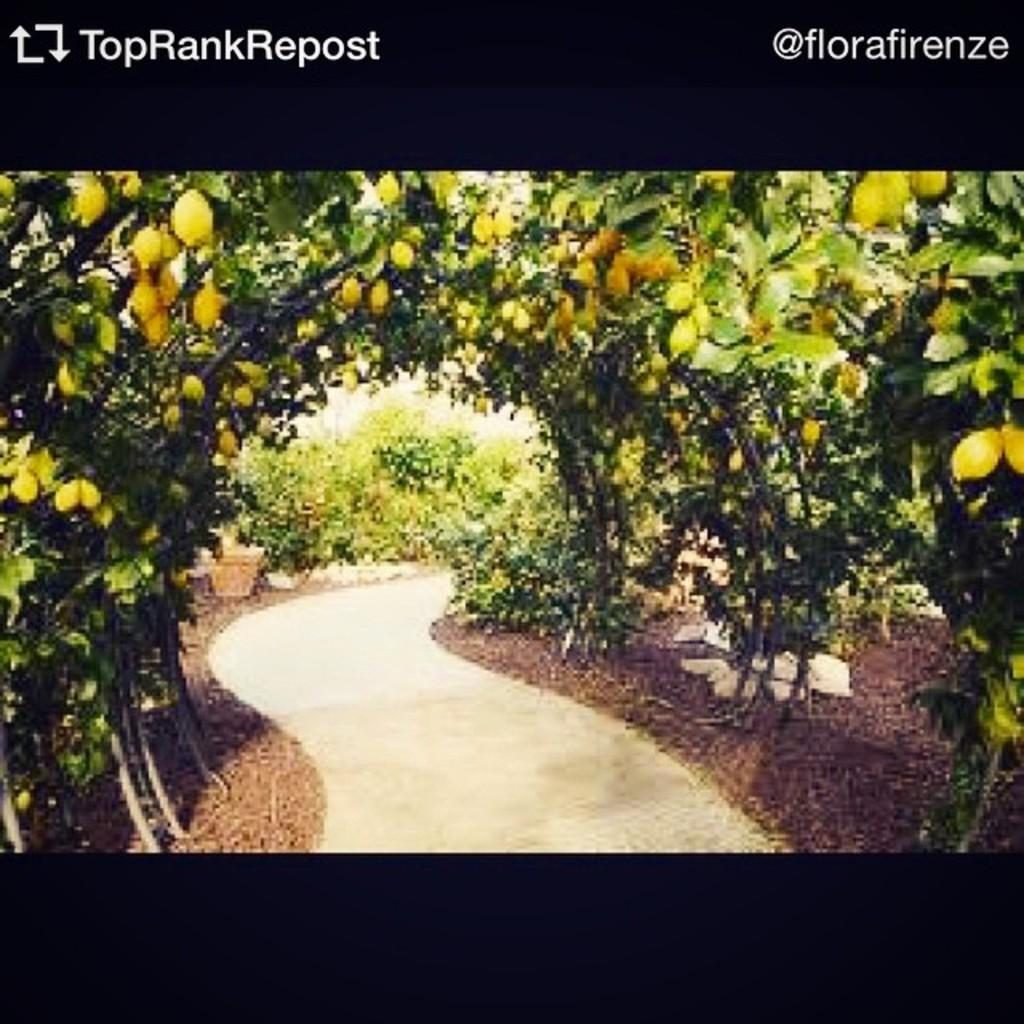What is the main subject of the image? There is a photograph in the image. What can be seen in the photograph? The photograph contains a pathway with plants on either side. What is the color of the fruits on the plants? The fruits on the plants are green in color. Can you tell me how many goats are visible in the image? There are no goats present in the image; it features a photograph of a pathway with plants and fruits. 